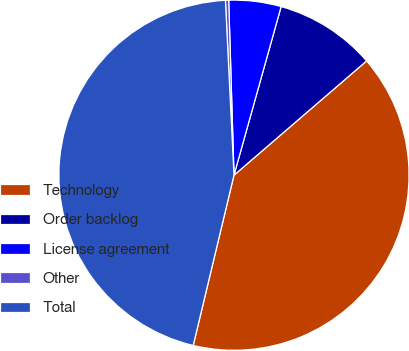<chart> <loc_0><loc_0><loc_500><loc_500><pie_chart><fcel>Technology<fcel>Order backlog<fcel>License agreement<fcel>Other<fcel>Total<nl><fcel>40.06%<fcel>9.34%<fcel>4.82%<fcel>0.3%<fcel>45.48%<nl></chart> 